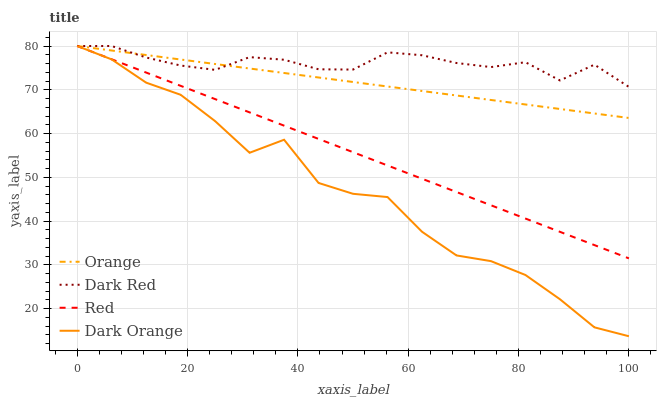Does Red have the minimum area under the curve?
Answer yes or no. No. Does Red have the maximum area under the curve?
Answer yes or no. No. Is Dark Red the smoothest?
Answer yes or no. No. Is Dark Red the roughest?
Answer yes or no. No. Does Red have the lowest value?
Answer yes or no. No. 